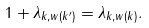<formula> <loc_0><loc_0><loc_500><loc_500>1 + \lambda _ { k , w ( k ^ { \prime } ) } = \lambda _ { k , w ( k ) } .</formula> 